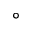<formula> <loc_0><loc_0><loc_500><loc_500>^ { \circ }</formula> 